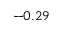Convert formula to latex. <formula><loc_0><loc_0><loc_500><loc_500>- 0 . 2 9</formula> 